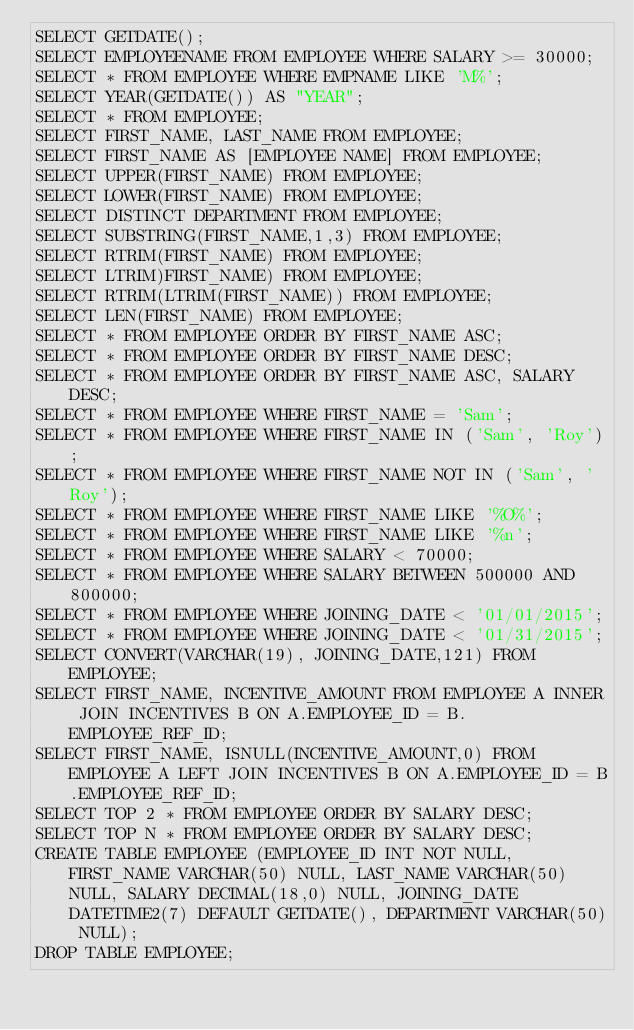Convert code to text. <code><loc_0><loc_0><loc_500><loc_500><_SQL_>SELECT GETDATE();
SELECT EMPLOYEENAME FROM EMPLOYEE WHERE SALARY >= 30000;
SELECT * FROM EMPLOYEE WHERE EMPNAME LIKE 'M%';
SELECT YEAR(GETDATE()) AS "YEAR";
SELECT * FROM EMPLOYEE;
SELECT FIRST_NAME, LAST_NAME FROM EMPLOYEE;
SELECT FIRST_NAME AS [EMPLOYEE NAME] FROM EMPLOYEE;
SELECT UPPER(FIRST_NAME) FROM EMPLOYEE;
SELECT LOWER(FIRST_NAME) FROM EMPLOYEE;
SELECT DISTINCT DEPARTMENT FROM EMPLOYEE;
SELECT SUBSTRING(FIRST_NAME,1,3) FROM EMPLOYEE;
SELECT RTRIM(FIRST_NAME) FROM EMPLOYEE;
SELECT LTRIM)FIRST_NAME) FROM EMPLOYEE;
SELECT RTRIM(LTRIM(FIRST_NAME)) FROM EMPLOYEE;
SELECT LEN(FIRST_NAME) FROM EMPLOYEE;
SELECT * FROM EMPLOYEE ORDER BY FIRST_NAME ASC;
SELECT * FROM EMPLOYEE ORDER BY FIRST_NAME DESC;
SELECT * FROM EMPLOYEE ORDER BY FIRST_NAME ASC, SALARY DESC;
SELECT * FROM EMPLOYEE WHERE FIRST_NAME = 'Sam';
SELECT * FROM EMPLOYEE WHERE FIRST_NAME IN ('Sam', 'Roy');
SELECT * FROM EMPLOYEE WHERE FIRST_NAME NOT IN ('Sam', 'Roy');
SELECT * FROM EMPLOYEE WHERE FIRST_NAME LIKE '%O%';
SELECT * FROM EMPLOYEE WHERE FIRST_NAME LIKE '%n';
SELECT * FROM EMPLOYEE WHERE SALARY < 70000;
SELECT * FROM EMPLOYEE WHERE SALARY BETWEEN 500000 AND 800000;
SELECT * FROM EMPLOYEE WHERE JOINING_DATE < '01/01/2015';
SELECT * FROM EMPLOYEE WHERE JOINING_DATE < '01/31/2015';
SELECT CONVERT(VARCHAR(19), JOINING_DATE,121) FROM EMPLOYEE;
SELECT FIRST_NAME, INCENTIVE_AMOUNT FROM EMPLOYEE A INNER JOIN INCENTIVES B ON A.EMPLOYEE_ID = B.EMPLOYEE_REF_ID;
SELECT FIRST_NAME, ISNULL(INCENTIVE_AMOUNT,0) FROM EMPLOYEE A LEFT JOIN INCENTIVES B ON A.EMPLOYEE_ID = B.EMPLOYEE_REF_ID;
SELECT TOP 2 * FROM EMPLOYEE ORDER BY SALARY DESC;
SELECT TOP N * FROM EMPLOYEE ORDER BY SALARY DESC;
CREATE TABLE EMPLOYEE (EMPLOYEE_ID INT NOT NULL, FIRST_NAME VARCHAR(50) NULL, LAST_NAME VARCHAR(50) NULL, SALARY DECIMAL(18,0) NULL, JOINING_DATE DATETIME2(7) DEFAULT GETDATE(), DEPARTMENT VARCHAR(50) NULL);
DROP TABLE EMPLOYEE;</code> 